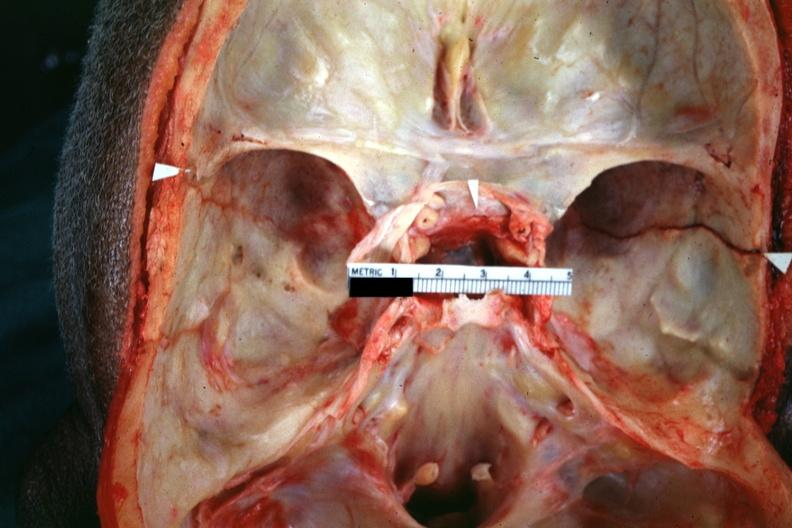what is present?
Answer the question using a single word or phrase. Bone, calvarium 